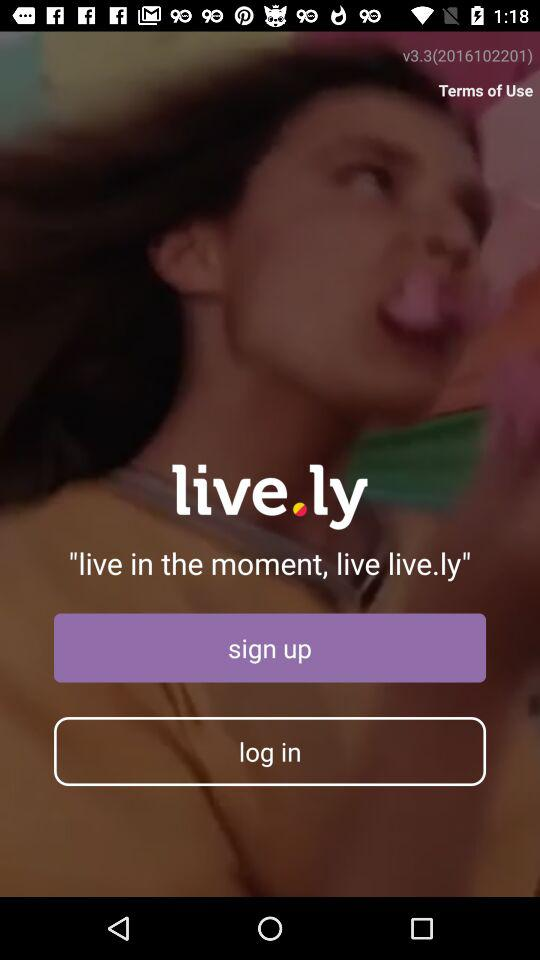What is the application name? The application name is "live.ly". 